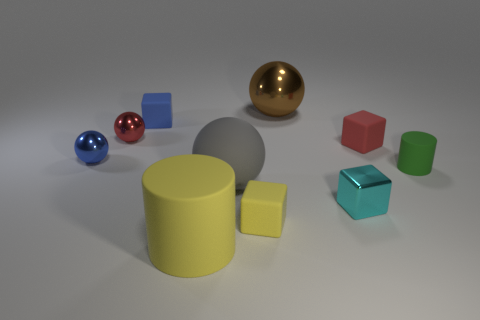There is a blue cube that is right of the tiny blue shiny thing; is its size the same as the cylinder left of the big gray matte thing?
Ensure brevity in your answer.  No. What is the color of the rubber cube that is in front of the green thing?
Your response must be concise. Yellow. There is a small block that is the same color as the big rubber cylinder; what is it made of?
Keep it short and to the point. Rubber. What number of tiny things are the same color as the large rubber cylinder?
Provide a short and direct response. 1. There is a gray object; does it have the same size as the metal object that is behind the blue matte block?
Offer a very short reply. Yes. How big is the matte block that is in front of the matte cylinder behind the cyan metal block that is in front of the tiny red matte thing?
Offer a terse response. Small. There is a green matte object; what number of large balls are behind it?
Your answer should be compact. 1. There is a small red object right of the shiny ball that is right of the large gray rubber thing; what is its material?
Your response must be concise. Rubber. Are there any other things that have the same size as the blue matte block?
Offer a terse response. Yes. Is the size of the blue block the same as the green matte cylinder?
Your answer should be compact. Yes. 